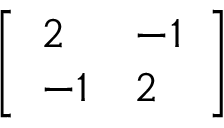Convert formula to latex. <formula><loc_0><loc_0><loc_500><loc_500>\left [ { \begin{array} { l l } { 2 } & { - 1 } \\ { - 1 } & { 2 } \end{array} } \right ]</formula> 